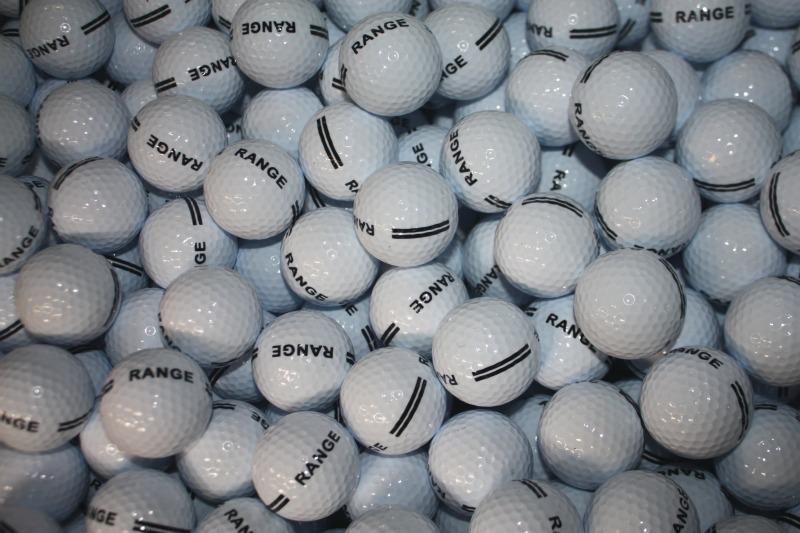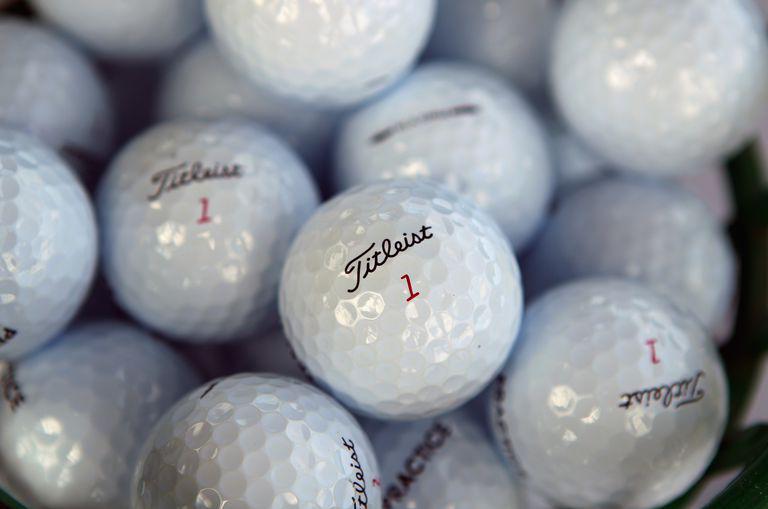The first image is the image on the left, the second image is the image on the right. Examine the images to the left and right. Is the description "Images show only white balls, and no image contains a golf club." accurate? Answer yes or no. Yes. The first image is the image on the left, the second image is the image on the right. Analyze the images presented: Is the assertion "There is visible dirt on at least three golf balls." valid? Answer yes or no. No. 